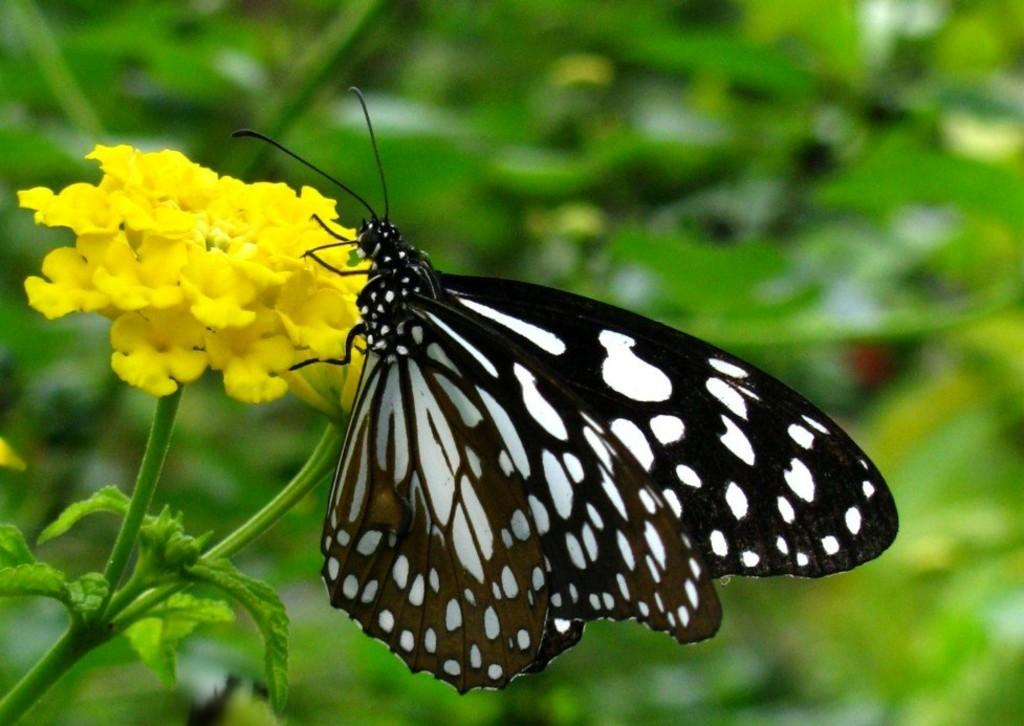What type of insect can be seen in the image? There is a butterfly in the image. What are the colors of the butterfly? The butterfly is black and white in color. What other living organism is present in the image? There is a flower plant in the image. What is the color of the flowers on the plant? The flowers on the plant are yellow in color. How would you describe the background of the image? The background of the image is blurred. How many eyes does the structure have in the image? There is no structure present in the image, and therefore no eyes can be counted. 